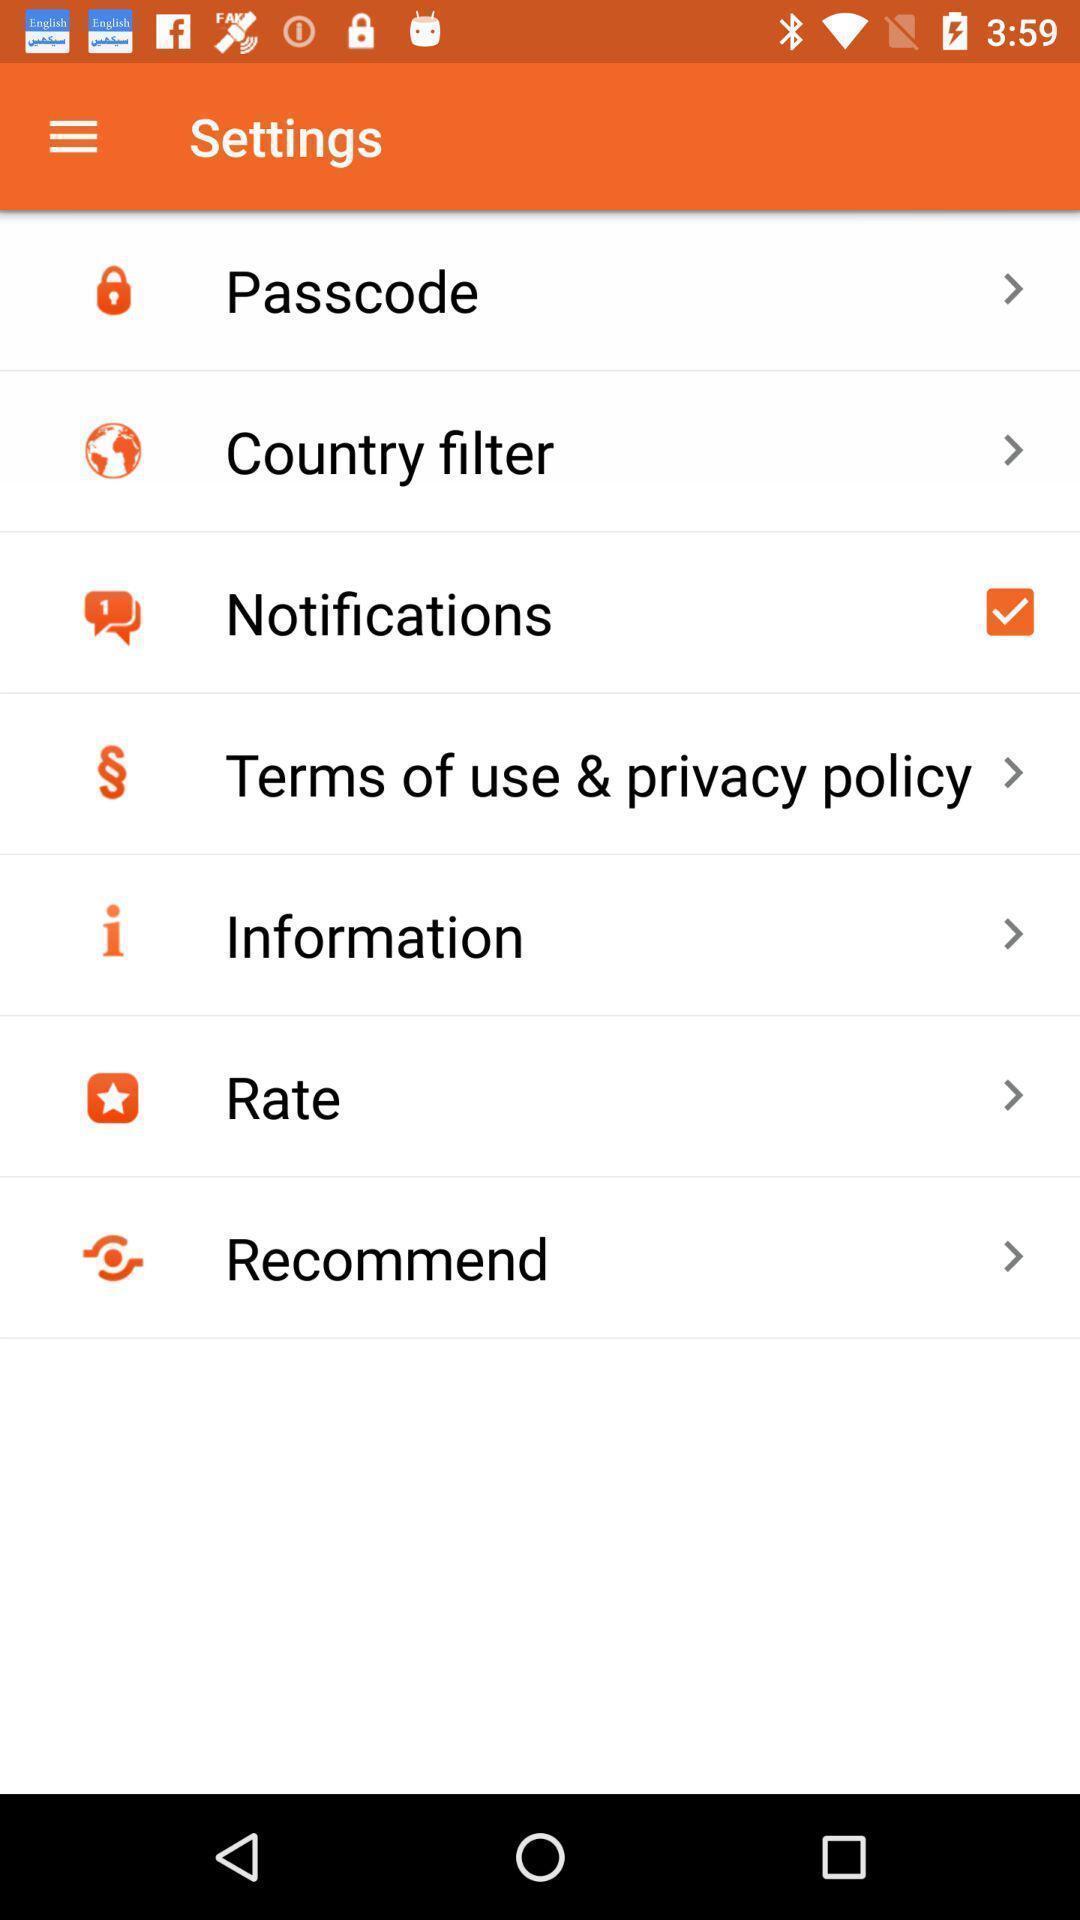Summarize the information in this screenshot. Settings page of a wallet app. 